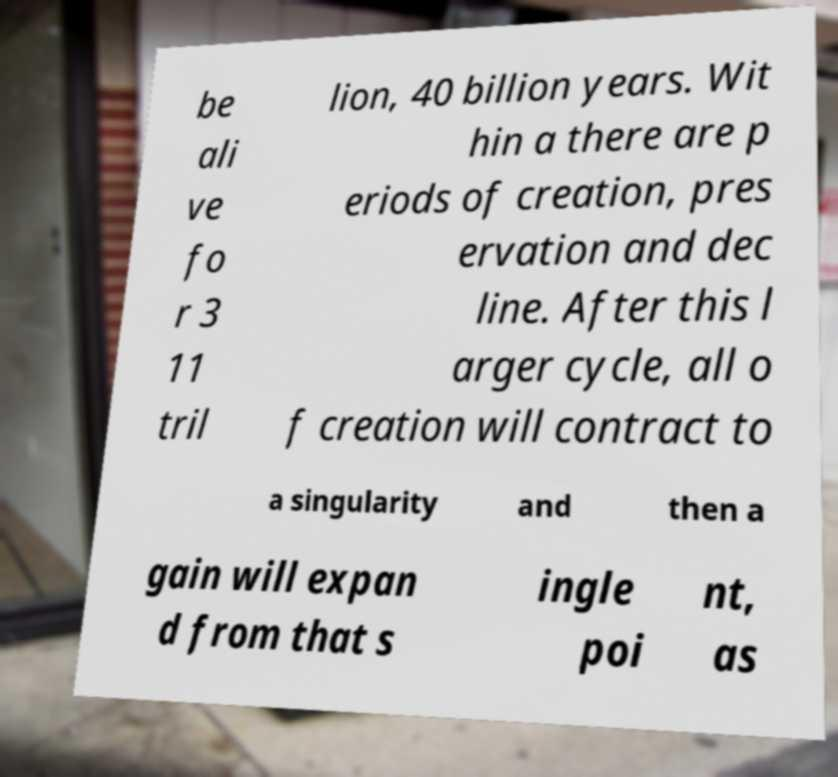Can you read and provide the text displayed in the image?This photo seems to have some interesting text. Can you extract and type it out for me? be ali ve fo r 3 11 tril lion, 40 billion years. Wit hin a there are p eriods of creation, pres ervation and dec line. After this l arger cycle, all o f creation will contract to a singularity and then a gain will expan d from that s ingle poi nt, as 